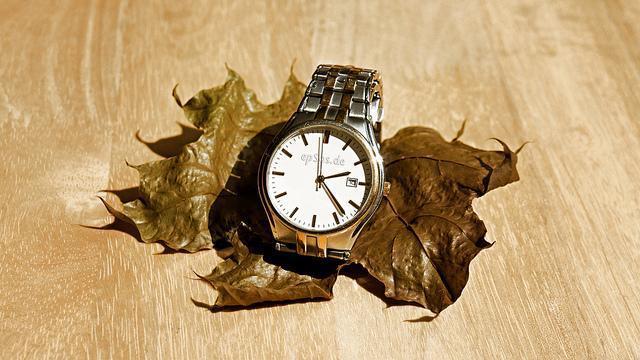How many train cars have some yellow on them?
Give a very brief answer. 0. 